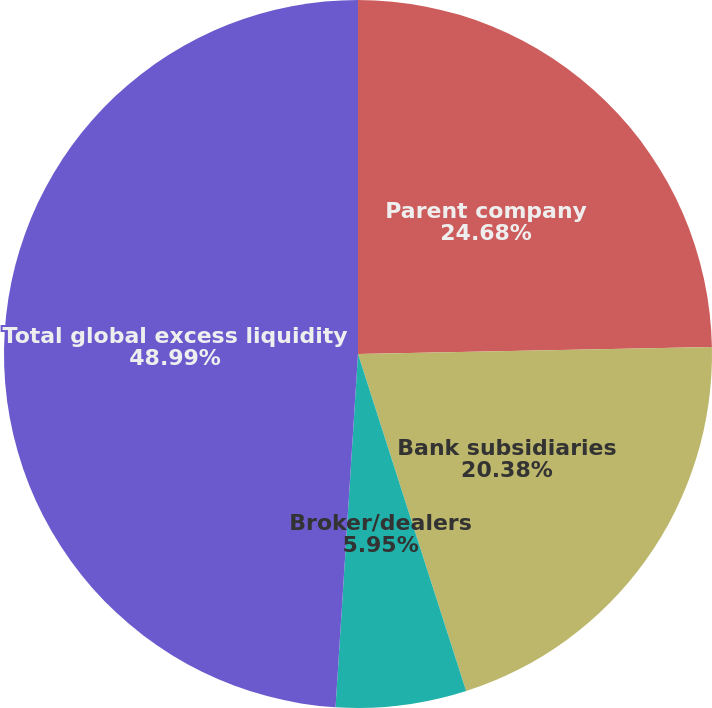<chart> <loc_0><loc_0><loc_500><loc_500><pie_chart><fcel>Parent company<fcel>Bank subsidiaries<fcel>Broker/dealers<fcel>Total global excess liquidity<nl><fcel>24.68%<fcel>20.38%<fcel>5.95%<fcel>48.99%<nl></chart> 